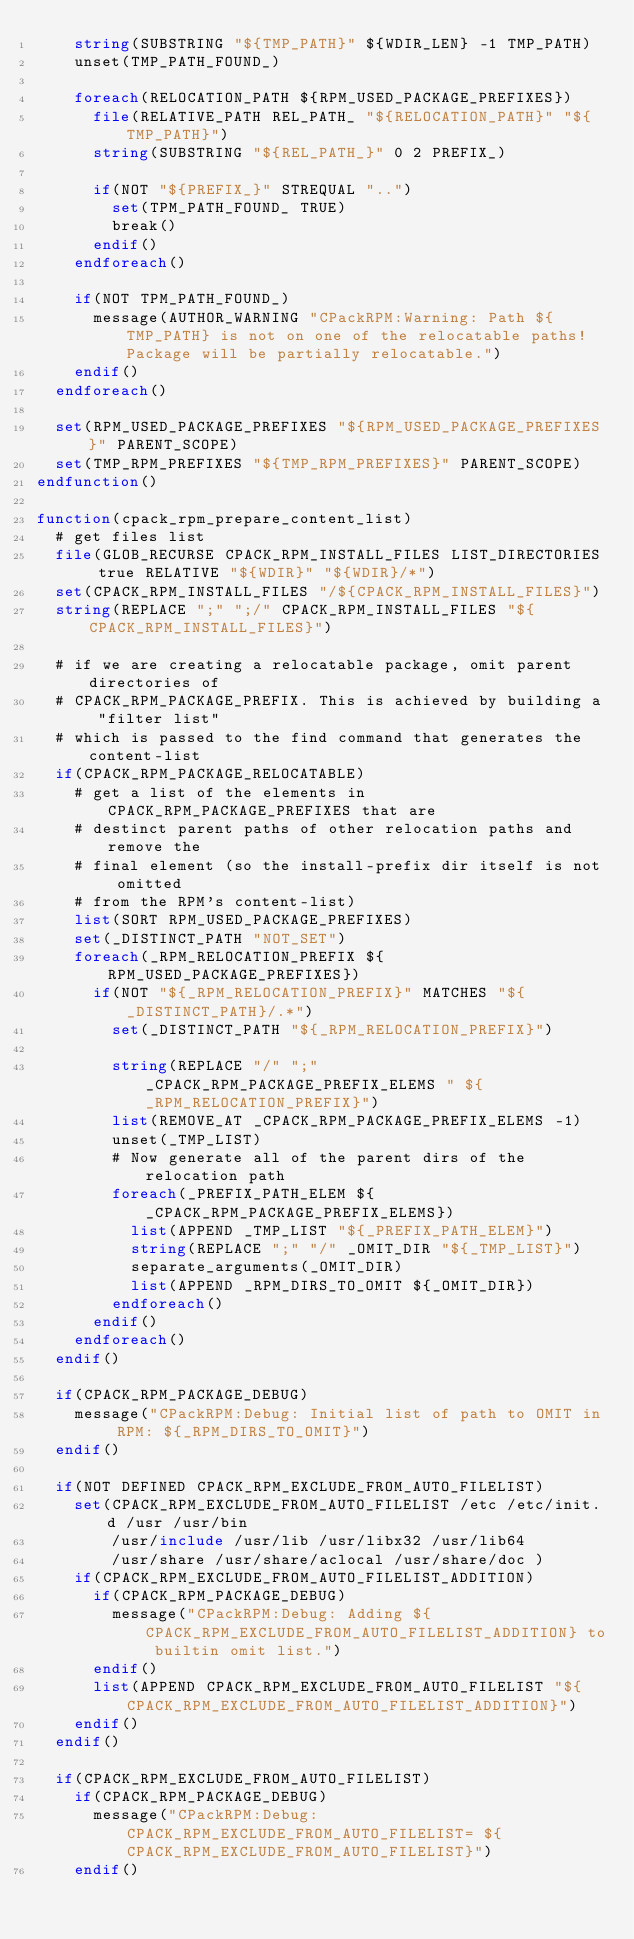<code> <loc_0><loc_0><loc_500><loc_500><_CMake_>    string(SUBSTRING "${TMP_PATH}" ${WDIR_LEN} -1 TMP_PATH)
    unset(TMP_PATH_FOUND_)

    foreach(RELOCATION_PATH ${RPM_USED_PACKAGE_PREFIXES})
      file(RELATIVE_PATH REL_PATH_ "${RELOCATION_PATH}" "${TMP_PATH}")
      string(SUBSTRING "${REL_PATH_}" 0 2 PREFIX_)

      if(NOT "${PREFIX_}" STREQUAL "..")
        set(TPM_PATH_FOUND_ TRUE)
        break()
      endif()
    endforeach()

    if(NOT TPM_PATH_FOUND_)
      message(AUTHOR_WARNING "CPackRPM:Warning: Path ${TMP_PATH} is not on one of the relocatable paths! Package will be partially relocatable.")
    endif()
  endforeach()

  set(RPM_USED_PACKAGE_PREFIXES "${RPM_USED_PACKAGE_PREFIXES}" PARENT_SCOPE)
  set(TMP_RPM_PREFIXES "${TMP_RPM_PREFIXES}" PARENT_SCOPE)
endfunction()

function(cpack_rpm_prepare_content_list)
  # get files list
  file(GLOB_RECURSE CPACK_RPM_INSTALL_FILES LIST_DIRECTORIES true RELATIVE "${WDIR}" "${WDIR}/*")
  set(CPACK_RPM_INSTALL_FILES "/${CPACK_RPM_INSTALL_FILES}")
  string(REPLACE ";" ";/" CPACK_RPM_INSTALL_FILES "${CPACK_RPM_INSTALL_FILES}")

  # if we are creating a relocatable package, omit parent directories of
  # CPACK_RPM_PACKAGE_PREFIX. This is achieved by building a "filter list"
  # which is passed to the find command that generates the content-list
  if(CPACK_RPM_PACKAGE_RELOCATABLE)
    # get a list of the elements in CPACK_RPM_PACKAGE_PREFIXES that are
    # destinct parent paths of other relocation paths and remove the
    # final element (so the install-prefix dir itself is not omitted
    # from the RPM's content-list)
    list(SORT RPM_USED_PACKAGE_PREFIXES)
    set(_DISTINCT_PATH "NOT_SET")
    foreach(_RPM_RELOCATION_PREFIX ${RPM_USED_PACKAGE_PREFIXES})
      if(NOT "${_RPM_RELOCATION_PREFIX}" MATCHES "${_DISTINCT_PATH}/.*")
        set(_DISTINCT_PATH "${_RPM_RELOCATION_PREFIX}")

        string(REPLACE "/" ";" _CPACK_RPM_PACKAGE_PREFIX_ELEMS " ${_RPM_RELOCATION_PREFIX}")
        list(REMOVE_AT _CPACK_RPM_PACKAGE_PREFIX_ELEMS -1)
        unset(_TMP_LIST)
        # Now generate all of the parent dirs of the relocation path
        foreach(_PREFIX_PATH_ELEM ${_CPACK_RPM_PACKAGE_PREFIX_ELEMS})
          list(APPEND _TMP_LIST "${_PREFIX_PATH_ELEM}")
          string(REPLACE ";" "/" _OMIT_DIR "${_TMP_LIST}")
          separate_arguments(_OMIT_DIR)
          list(APPEND _RPM_DIRS_TO_OMIT ${_OMIT_DIR})
        endforeach()
      endif()
    endforeach()
  endif()

  if(CPACK_RPM_PACKAGE_DEBUG)
    message("CPackRPM:Debug: Initial list of path to OMIT in RPM: ${_RPM_DIRS_TO_OMIT}")
  endif()

  if(NOT DEFINED CPACK_RPM_EXCLUDE_FROM_AUTO_FILELIST)
    set(CPACK_RPM_EXCLUDE_FROM_AUTO_FILELIST /etc /etc/init.d /usr /usr/bin
        /usr/include /usr/lib /usr/libx32 /usr/lib64
        /usr/share /usr/share/aclocal /usr/share/doc )
    if(CPACK_RPM_EXCLUDE_FROM_AUTO_FILELIST_ADDITION)
      if(CPACK_RPM_PACKAGE_DEBUG)
        message("CPackRPM:Debug: Adding ${CPACK_RPM_EXCLUDE_FROM_AUTO_FILELIST_ADDITION} to builtin omit list.")
      endif()
      list(APPEND CPACK_RPM_EXCLUDE_FROM_AUTO_FILELIST "${CPACK_RPM_EXCLUDE_FROM_AUTO_FILELIST_ADDITION}")
    endif()
  endif()

  if(CPACK_RPM_EXCLUDE_FROM_AUTO_FILELIST)
    if(CPACK_RPM_PACKAGE_DEBUG)
      message("CPackRPM:Debug: CPACK_RPM_EXCLUDE_FROM_AUTO_FILELIST= ${CPACK_RPM_EXCLUDE_FROM_AUTO_FILELIST}")
    endif()</code> 